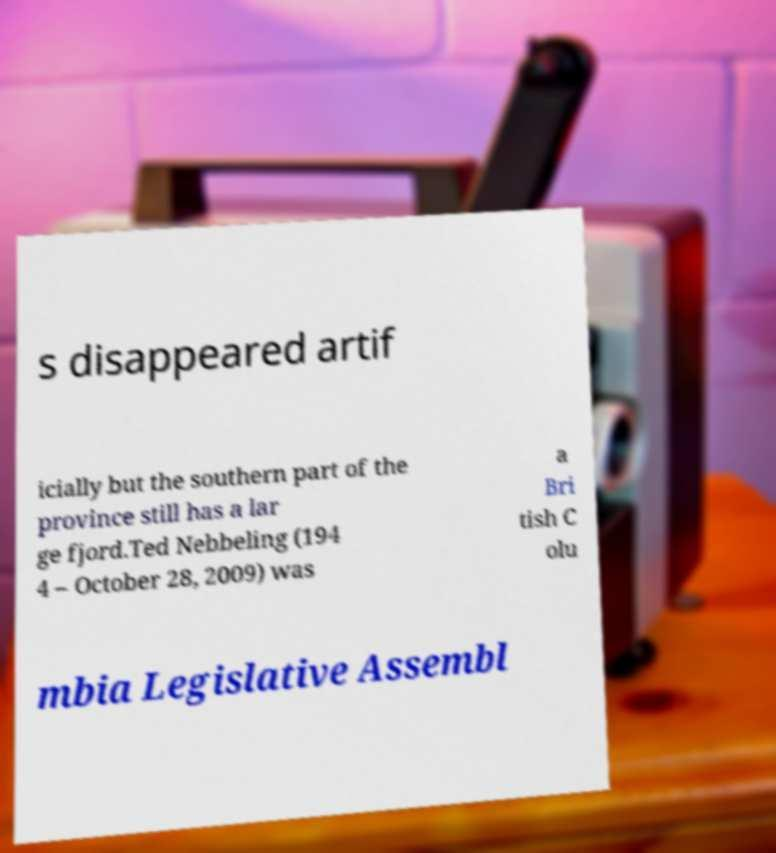I need the written content from this picture converted into text. Can you do that? s disappeared artif icially but the southern part of the province still has a lar ge fjord.Ted Nebbeling (194 4 – October 28, 2009) was a Bri tish C olu mbia Legislative Assembl 